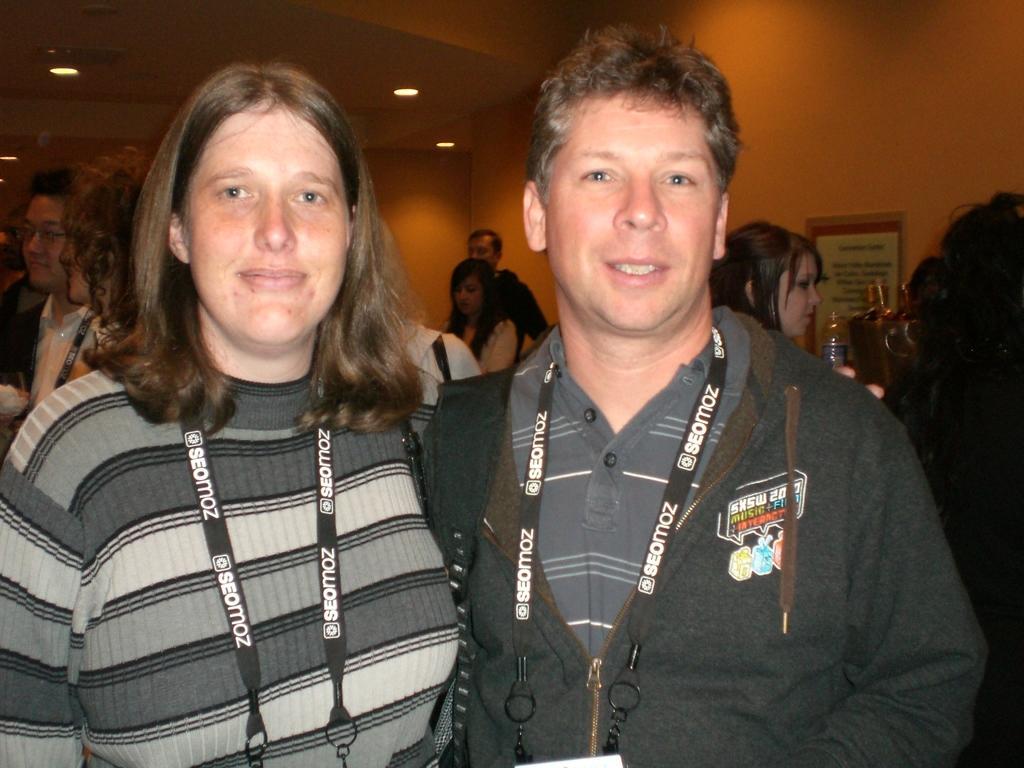Can you describe this image briefly? In the middle of the image we can see a man and a woman. In the background we can see people, wall, ceiling, lights, board, bottle, and other objects. 